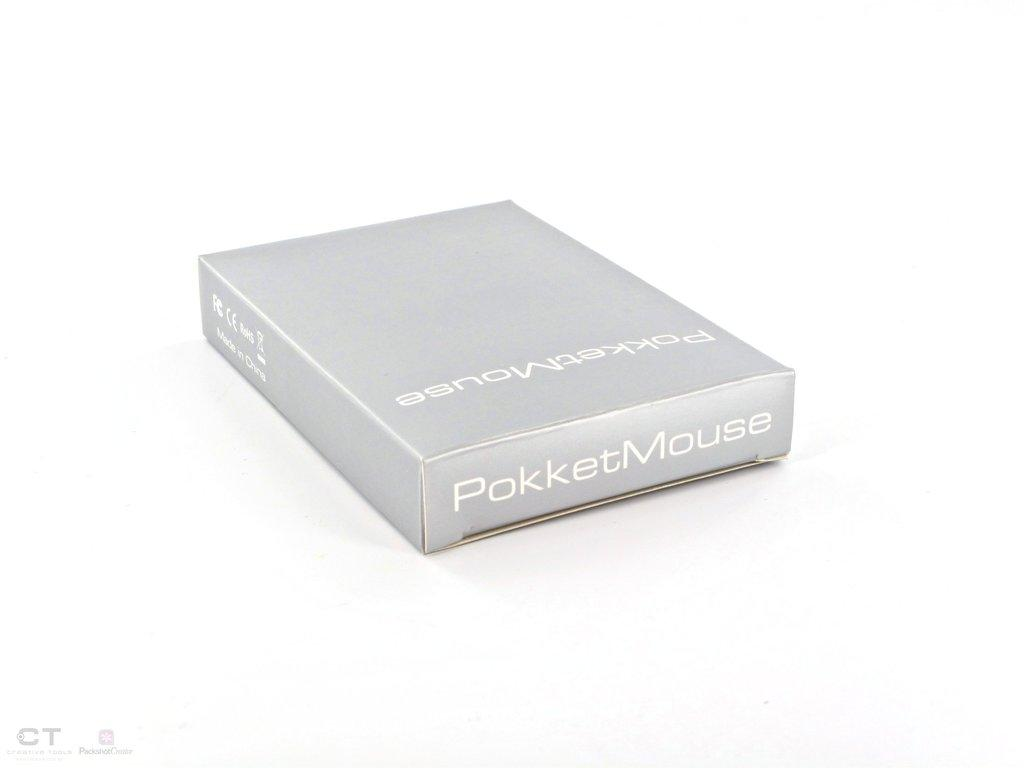<image>
Provide a brief description of the given image. A grey box with the words Pokket Mouse written on the outside 